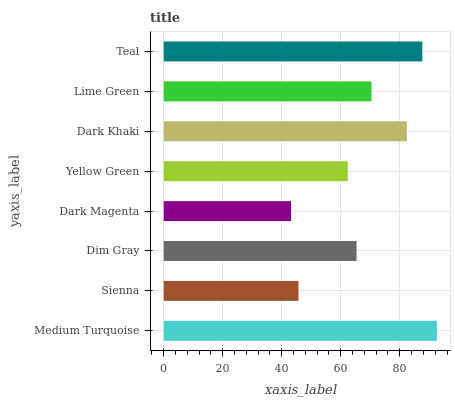Is Dark Magenta the minimum?
Answer yes or no. Yes. Is Medium Turquoise the maximum?
Answer yes or no. Yes. Is Sienna the minimum?
Answer yes or no. No. Is Sienna the maximum?
Answer yes or no. No. Is Medium Turquoise greater than Sienna?
Answer yes or no. Yes. Is Sienna less than Medium Turquoise?
Answer yes or no. Yes. Is Sienna greater than Medium Turquoise?
Answer yes or no. No. Is Medium Turquoise less than Sienna?
Answer yes or no. No. Is Lime Green the high median?
Answer yes or no. Yes. Is Dim Gray the low median?
Answer yes or no. Yes. Is Medium Turquoise the high median?
Answer yes or no. No. Is Sienna the low median?
Answer yes or no. No. 